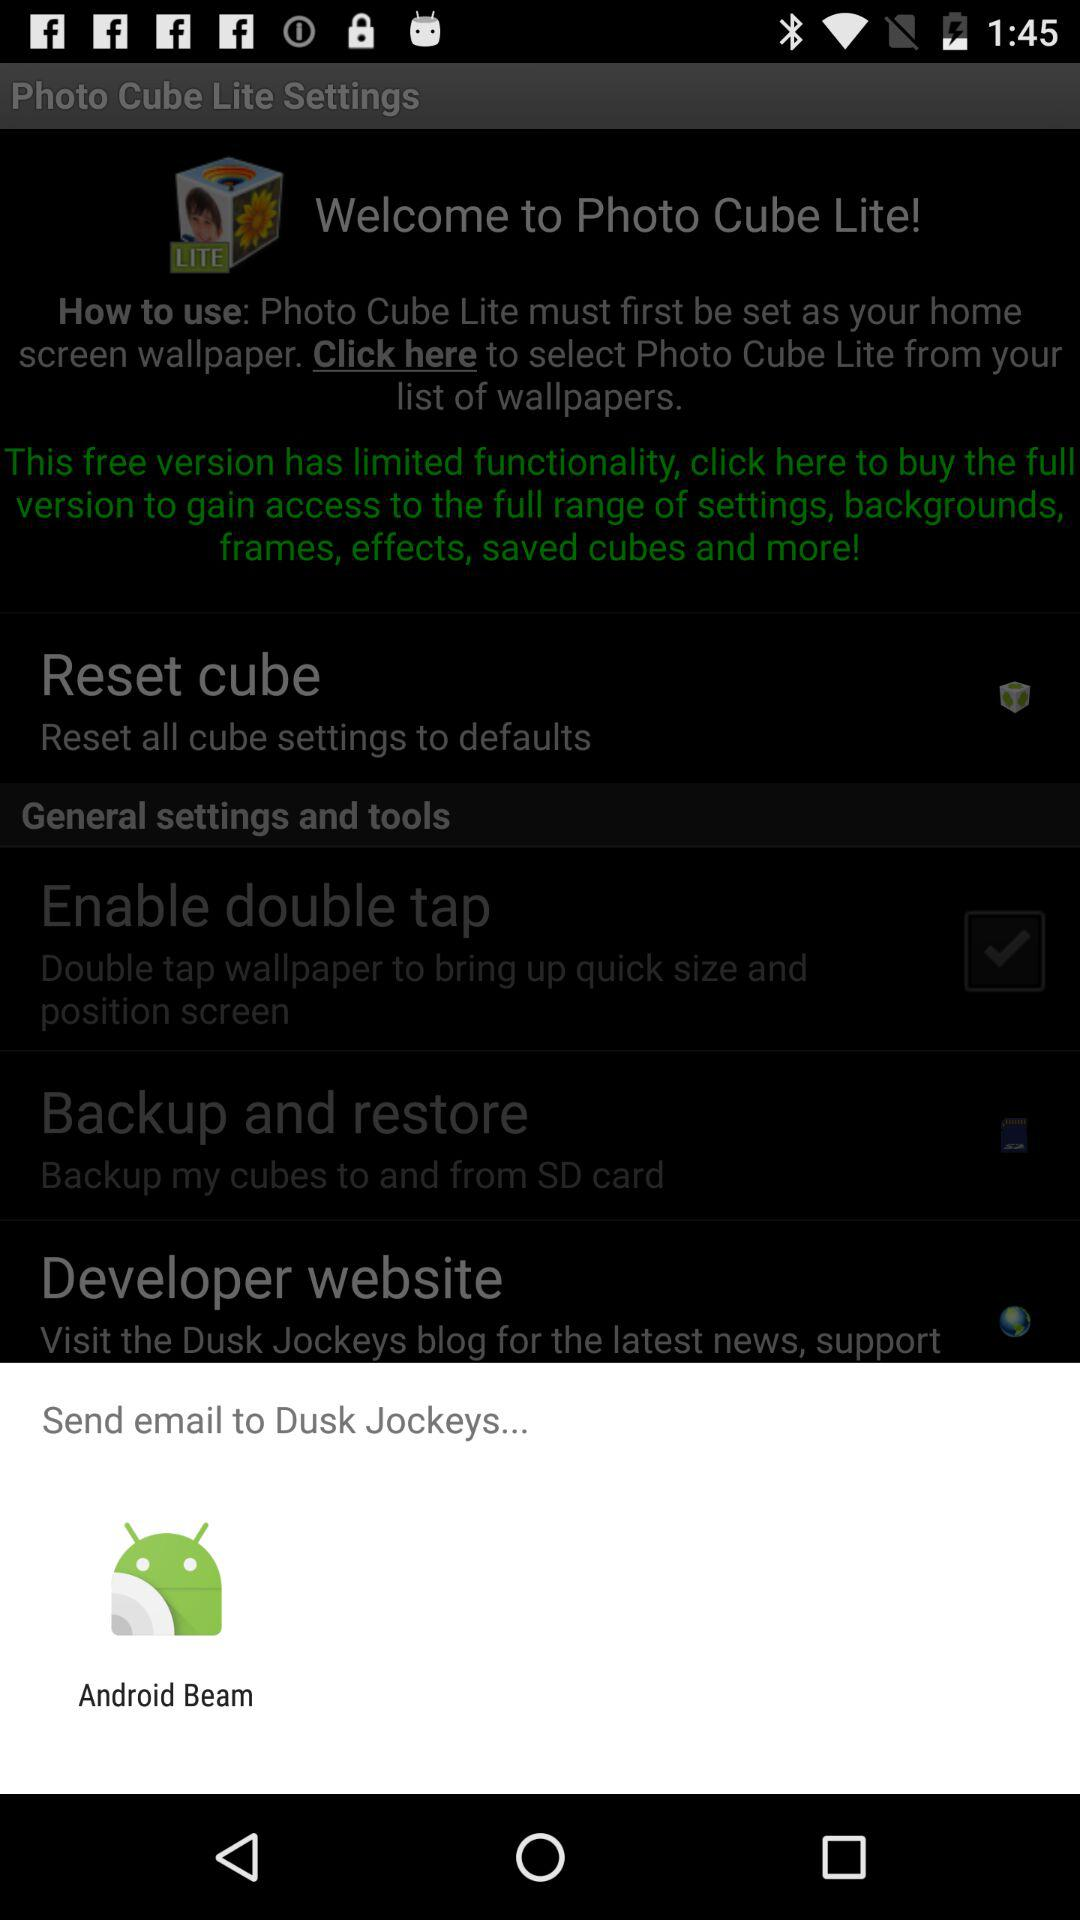How much does the full version of "Photo Cube Lite" cost?
When the provided information is insufficient, respond with <no answer>. <no answer> 